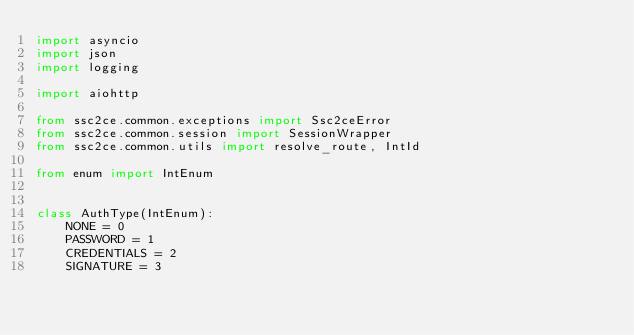<code> <loc_0><loc_0><loc_500><loc_500><_Python_>import asyncio
import json
import logging

import aiohttp

from ssc2ce.common.exceptions import Ssc2ceError
from ssc2ce.common.session import SessionWrapper
from ssc2ce.common.utils import resolve_route, IntId

from enum import IntEnum


class AuthType(IntEnum):
    NONE = 0
    PASSWORD = 1
    CREDENTIALS = 2
    SIGNATURE = 3

</code> 